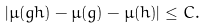<formula> <loc_0><loc_0><loc_500><loc_500>| \mu ( g h ) - \mu ( g ) - \mu ( h ) | \leq C .</formula> 